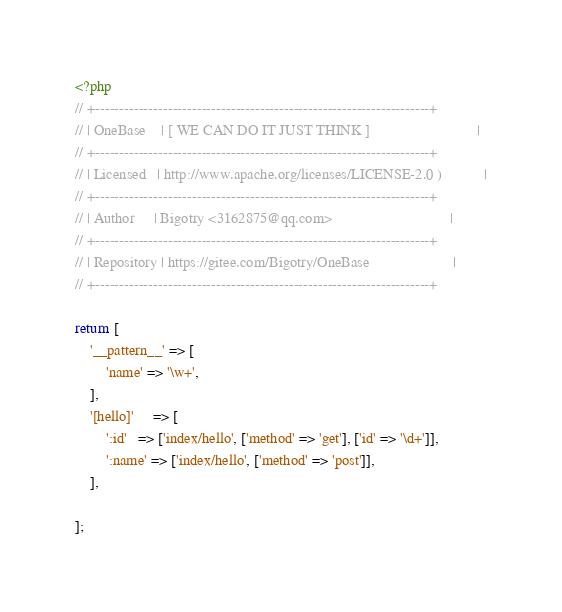Convert code to text. <code><loc_0><loc_0><loc_500><loc_500><_PHP_><?php
// +---------------------------------------------------------------------+
// | OneBase    | [ WE CAN DO IT JUST THINK ]                            |
// +---------------------------------------------------------------------+
// | Licensed   | http://www.apache.org/licenses/LICENSE-2.0 )           |
// +---------------------------------------------------------------------+
// | Author     | Bigotry <3162875@qq.com>                               |
// +---------------------------------------------------------------------+
// | Repository | https://gitee.com/Bigotry/OneBase                      |
// +---------------------------------------------------------------------+

return [
    '__pattern__' => [
        'name' => '\w+',
    ],
    '[hello]'     => [
        ':id'   => ['index/hello', ['method' => 'get'], ['id' => '\d+']],
        ':name' => ['index/hello', ['method' => 'post']],
    ],

];
</code> 